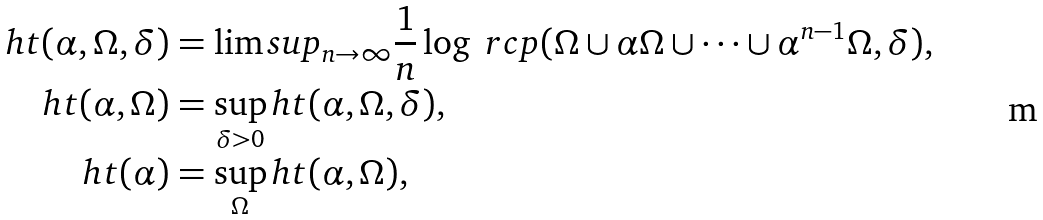<formula> <loc_0><loc_0><loc_500><loc_500>h t ( \alpha , \Omega , \delta ) & = \lim s u p _ { n \to \infty } \frac { 1 } { n } \log \ r c p ( \Omega \cup \alpha \Omega \cup \cdots \cup \alpha ^ { n - 1 } \Omega , \delta ) , \\ h t ( \alpha , \Omega ) & = \sup _ { \delta > 0 } h t ( \alpha , \Omega , \delta ) , \\ h t ( \alpha ) & = \sup _ { \Omega } h t ( \alpha , \Omega ) ,</formula> 